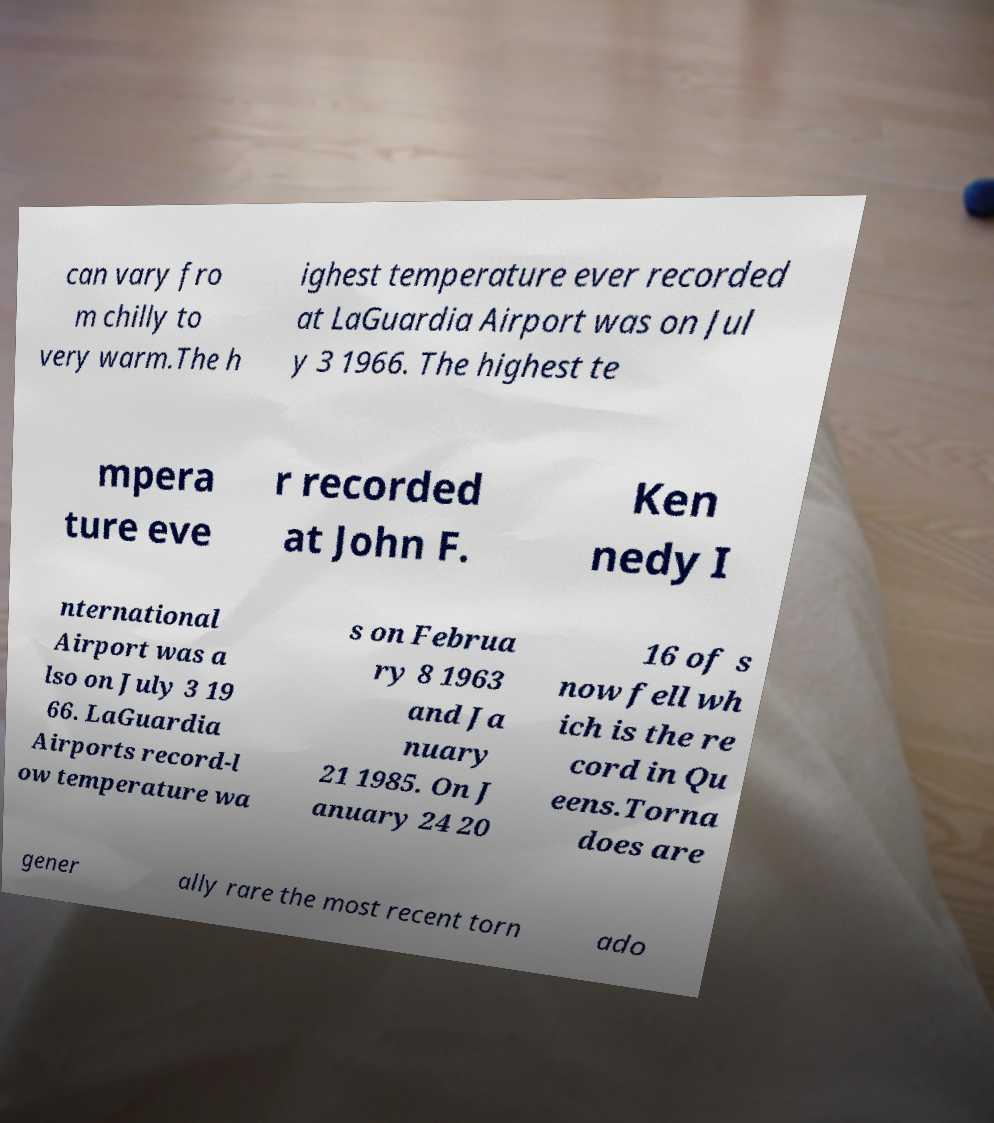I need the written content from this picture converted into text. Can you do that? can vary fro m chilly to very warm.The h ighest temperature ever recorded at LaGuardia Airport was on Jul y 3 1966. The highest te mpera ture eve r recorded at John F. Ken nedy I nternational Airport was a lso on July 3 19 66. LaGuardia Airports record-l ow temperature wa s on Februa ry 8 1963 and Ja nuary 21 1985. On J anuary 24 20 16 of s now fell wh ich is the re cord in Qu eens.Torna does are gener ally rare the most recent torn ado 